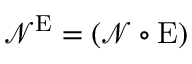Convert formula to latex. <formula><loc_0><loc_0><loc_500><loc_500>\mathcal { N } ^ { E } = ( \mathcal { N } \circ E )</formula> 